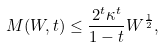Convert formula to latex. <formula><loc_0><loc_0><loc_500><loc_500>M ( W , t ) \leq \frac { 2 ^ { t } \kappa ^ { t } } { 1 - t } W ^ { \frac { 1 } { 2 } } ,</formula> 